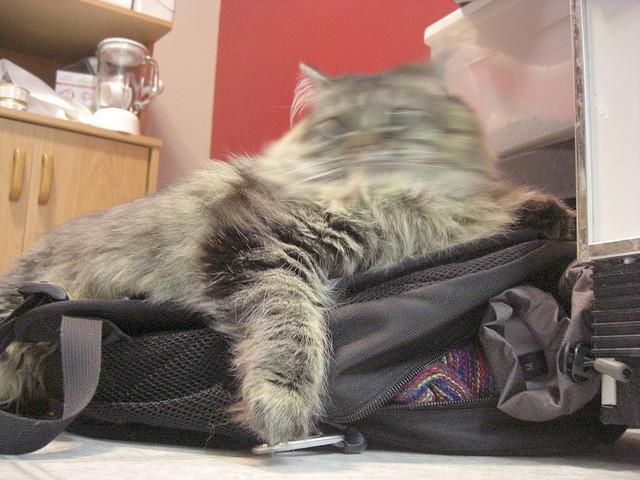How many men are wearing blue jeans?
Give a very brief answer. 0. 